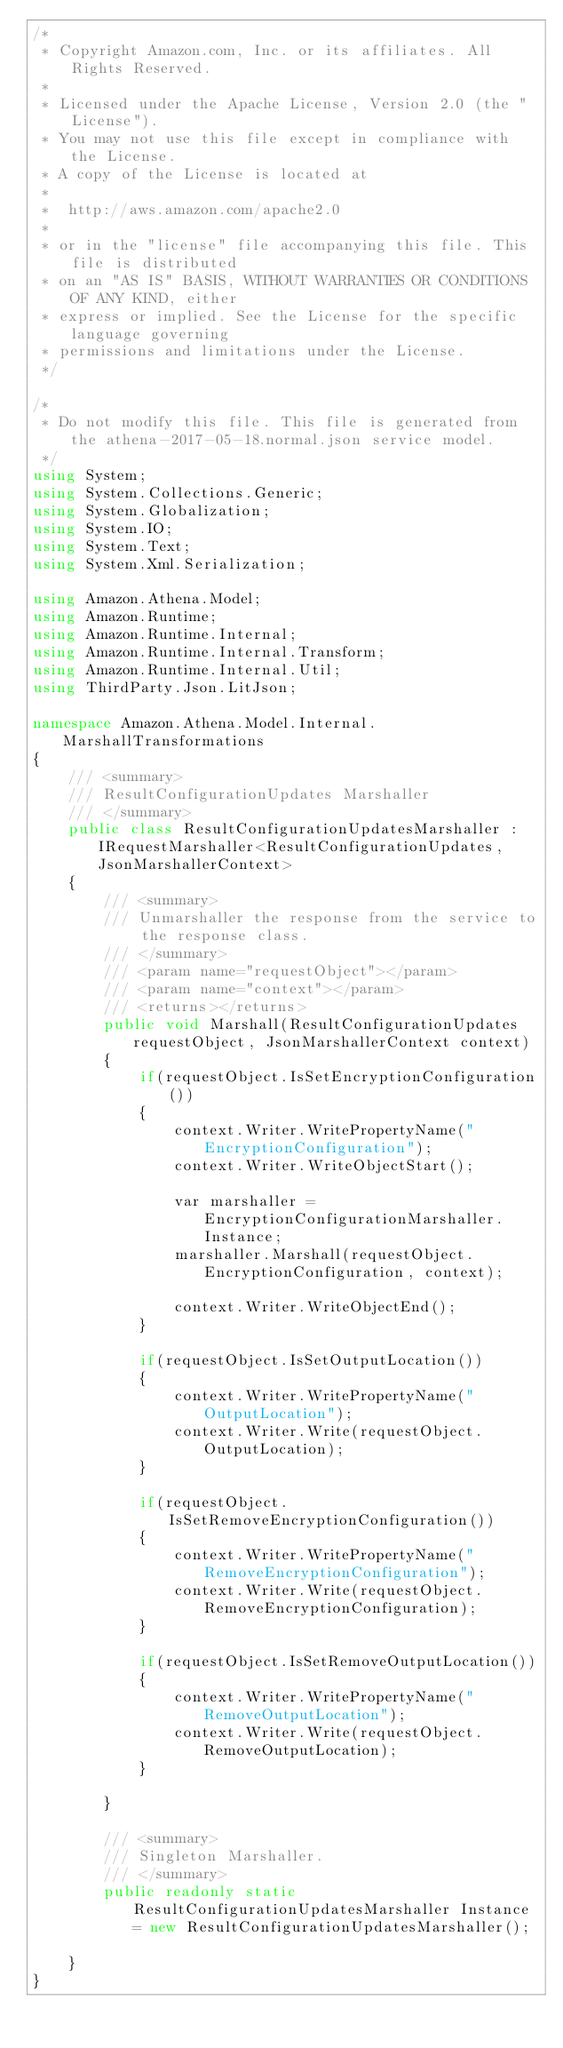Convert code to text. <code><loc_0><loc_0><loc_500><loc_500><_C#_>/*
 * Copyright Amazon.com, Inc. or its affiliates. All Rights Reserved.
 * 
 * Licensed under the Apache License, Version 2.0 (the "License").
 * You may not use this file except in compliance with the License.
 * A copy of the License is located at
 * 
 *  http://aws.amazon.com/apache2.0
 * 
 * or in the "license" file accompanying this file. This file is distributed
 * on an "AS IS" BASIS, WITHOUT WARRANTIES OR CONDITIONS OF ANY KIND, either
 * express or implied. See the License for the specific language governing
 * permissions and limitations under the License.
 */

/*
 * Do not modify this file. This file is generated from the athena-2017-05-18.normal.json service model.
 */
using System;
using System.Collections.Generic;
using System.Globalization;
using System.IO;
using System.Text;
using System.Xml.Serialization;

using Amazon.Athena.Model;
using Amazon.Runtime;
using Amazon.Runtime.Internal;
using Amazon.Runtime.Internal.Transform;
using Amazon.Runtime.Internal.Util;
using ThirdParty.Json.LitJson;

namespace Amazon.Athena.Model.Internal.MarshallTransformations
{
    /// <summary>
    /// ResultConfigurationUpdates Marshaller
    /// </summary>       
    public class ResultConfigurationUpdatesMarshaller : IRequestMarshaller<ResultConfigurationUpdates, JsonMarshallerContext> 
    {
        /// <summary>
        /// Unmarshaller the response from the service to the response class.
        /// </summary>  
        /// <param name="requestObject"></param>
        /// <param name="context"></param>
        /// <returns></returns>
        public void Marshall(ResultConfigurationUpdates requestObject, JsonMarshallerContext context)
        {
            if(requestObject.IsSetEncryptionConfiguration())
            {
                context.Writer.WritePropertyName("EncryptionConfiguration");
                context.Writer.WriteObjectStart();

                var marshaller = EncryptionConfigurationMarshaller.Instance;
                marshaller.Marshall(requestObject.EncryptionConfiguration, context);

                context.Writer.WriteObjectEnd();
            }

            if(requestObject.IsSetOutputLocation())
            {
                context.Writer.WritePropertyName("OutputLocation");
                context.Writer.Write(requestObject.OutputLocation);
            }

            if(requestObject.IsSetRemoveEncryptionConfiguration())
            {
                context.Writer.WritePropertyName("RemoveEncryptionConfiguration");
                context.Writer.Write(requestObject.RemoveEncryptionConfiguration);
            }

            if(requestObject.IsSetRemoveOutputLocation())
            {
                context.Writer.WritePropertyName("RemoveOutputLocation");
                context.Writer.Write(requestObject.RemoveOutputLocation);
            }

        }

        /// <summary>
        /// Singleton Marshaller.
        /// </summary>  
        public readonly static ResultConfigurationUpdatesMarshaller Instance = new ResultConfigurationUpdatesMarshaller();

    }
}</code> 